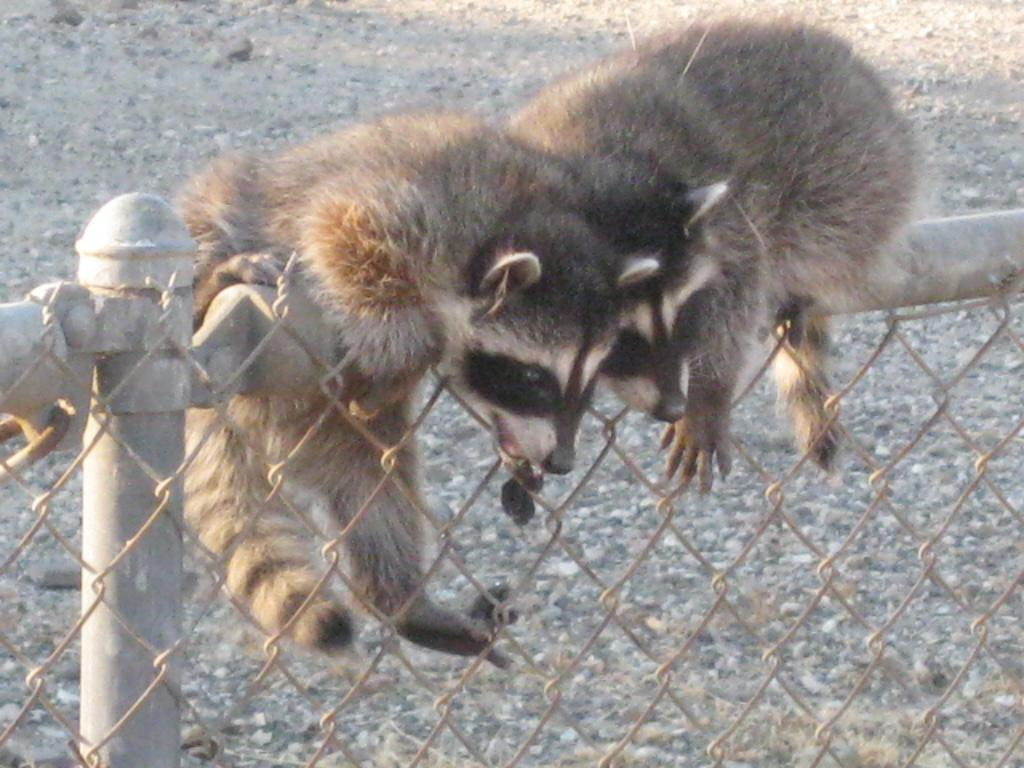What is the main feature in the center of the image? There is a boundary in the center of the image. What animals can be seen on the boundary? There are two raccoons on the boundary. What type of straw is being used by the raccoons in the image? There is no straw present in the image; the raccoons are on the boundary without any visible objects. 